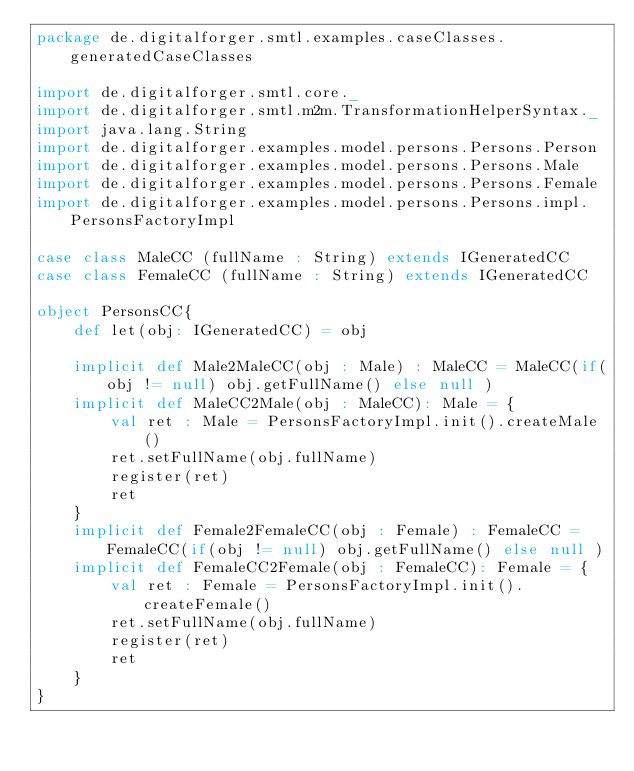Convert code to text. <code><loc_0><loc_0><loc_500><loc_500><_Scala_>package de.digitalforger.smtl.examples.caseClasses.generatedCaseClasses

import de.digitalforger.smtl.core._
import de.digitalforger.smtl.m2m.TransformationHelperSyntax._
import java.lang.String
import de.digitalforger.examples.model.persons.Persons.Person
import de.digitalforger.examples.model.persons.Persons.Male
import de.digitalforger.examples.model.persons.Persons.Female
import de.digitalforger.examples.model.persons.Persons.impl.PersonsFactoryImpl

case class MaleCC (fullName : String) extends IGeneratedCC
case class FemaleCC (fullName : String) extends IGeneratedCC

object PersonsCC{
	def let(obj: IGeneratedCC) = obj

	implicit def Male2MaleCC(obj : Male) : MaleCC = MaleCC(if(obj != null) obj.getFullName() else null )
	implicit def MaleCC2Male(obj : MaleCC): Male = { 
		val ret : Male = PersonsFactoryImpl.init().createMale()
		ret.setFullName(obj.fullName)
		register(ret)
		ret
	}
	implicit def Female2FemaleCC(obj : Female) : FemaleCC = FemaleCC(if(obj != null) obj.getFullName() else null )
	implicit def FemaleCC2Female(obj : FemaleCC): Female = { 
		val ret : Female = PersonsFactoryImpl.init().createFemale()
		ret.setFullName(obj.fullName)
		register(ret)
		ret
	}
}
</code> 